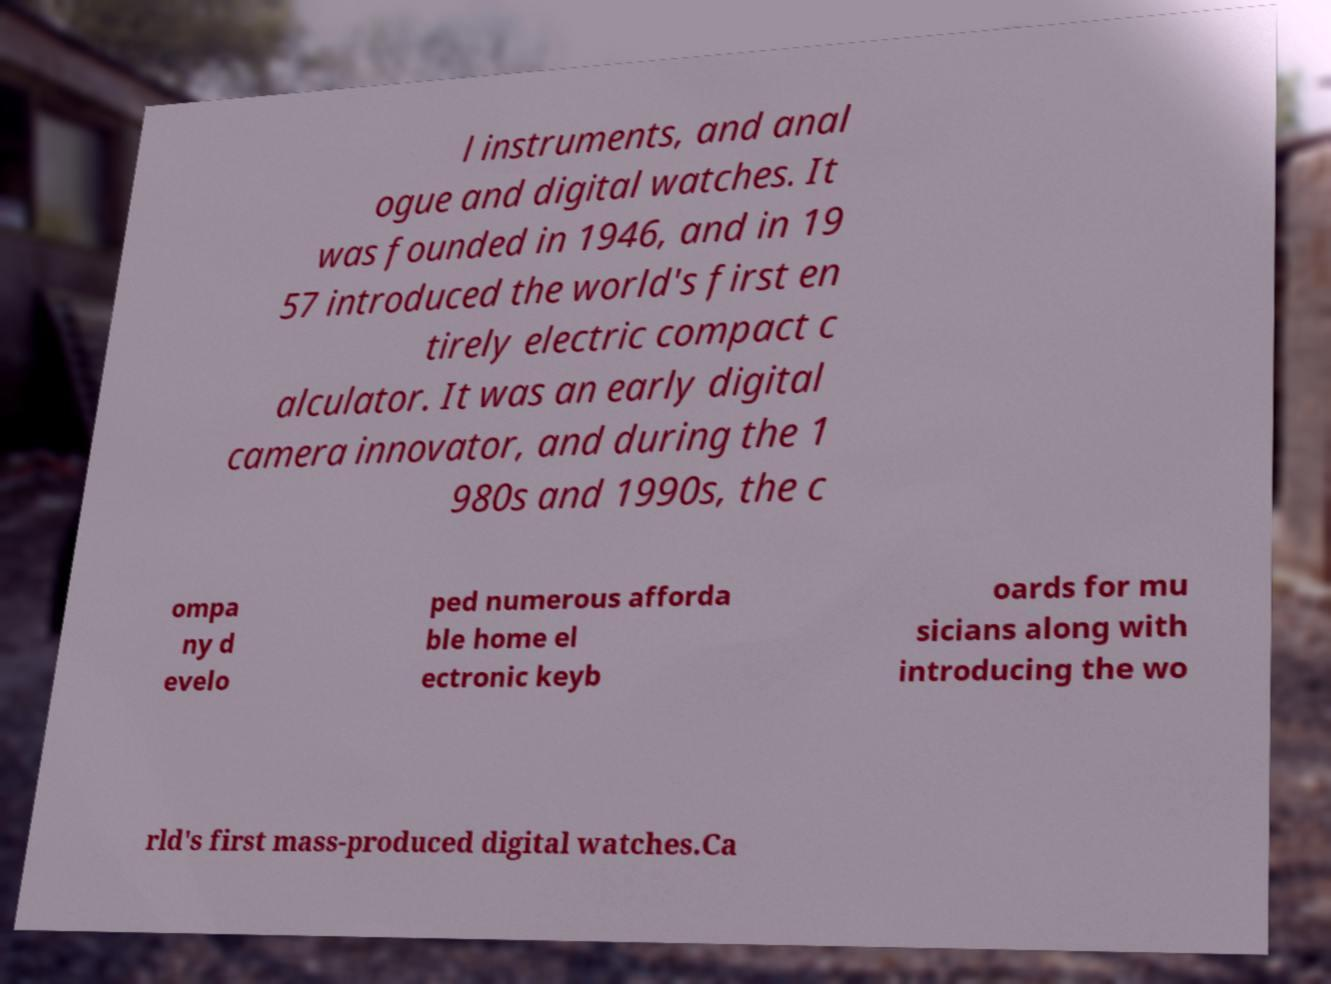There's text embedded in this image that I need extracted. Can you transcribe it verbatim? l instruments, and anal ogue and digital watches. It was founded in 1946, and in 19 57 introduced the world's first en tirely electric compact c alculator. It was an early digital camera innovator, and during the 1 980s and 1990s, the c ompa ny d evelo ped numerous afforda ble home el ectronic keyb oards for mu sicians along with introducing the wo rld's first mass-produced digital watches.Ca 